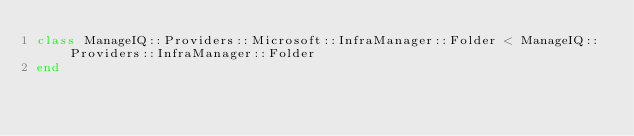Convert code to text. <code><loc_0><loc_0><loc_500><loc_500><_Ruby_>class ManageIQ::Providers::Microsoft::InfraManager::Folder < ManageIQ::Providers::InfraManager::Folder
end
</code> 